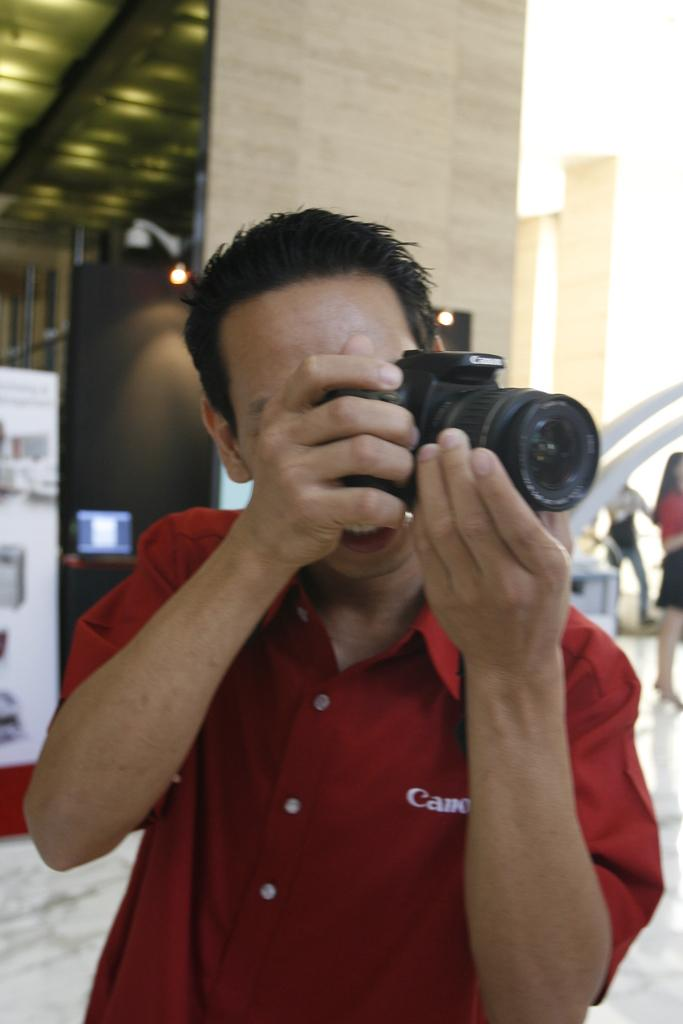Who is the main subject in the image? There is a man in the image. What is the man wearing? The man is wearing a red shirt. What is the man holding in his hand? The man is holding a camera in his hand. What can be seen in the background of the image? There are posters and a wall visible in the background. Are there any other people in the image? Yes, there are people standing to the right side of the image. What type of riddle can be seen on the wall in the image? There is no riddle visible on the wall in the image. 